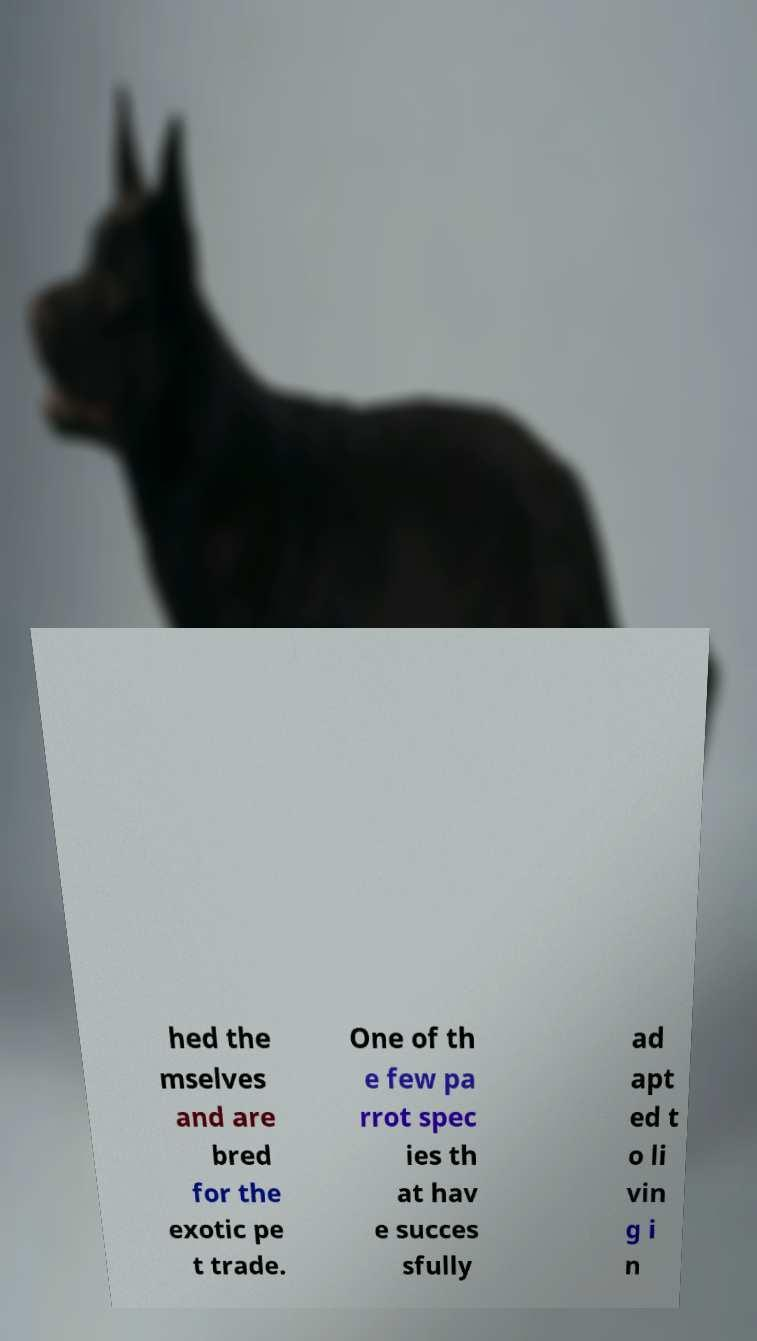Can you read and provide the text displayed in the image?This photo seems to have some interesting text. Can you extract and type it out for me? hed the mselves and are bred for the exotic pe t trade. One of th e few pa rrot spec ies th at hav e succes sfully ad apt ed t o li vin g i n 